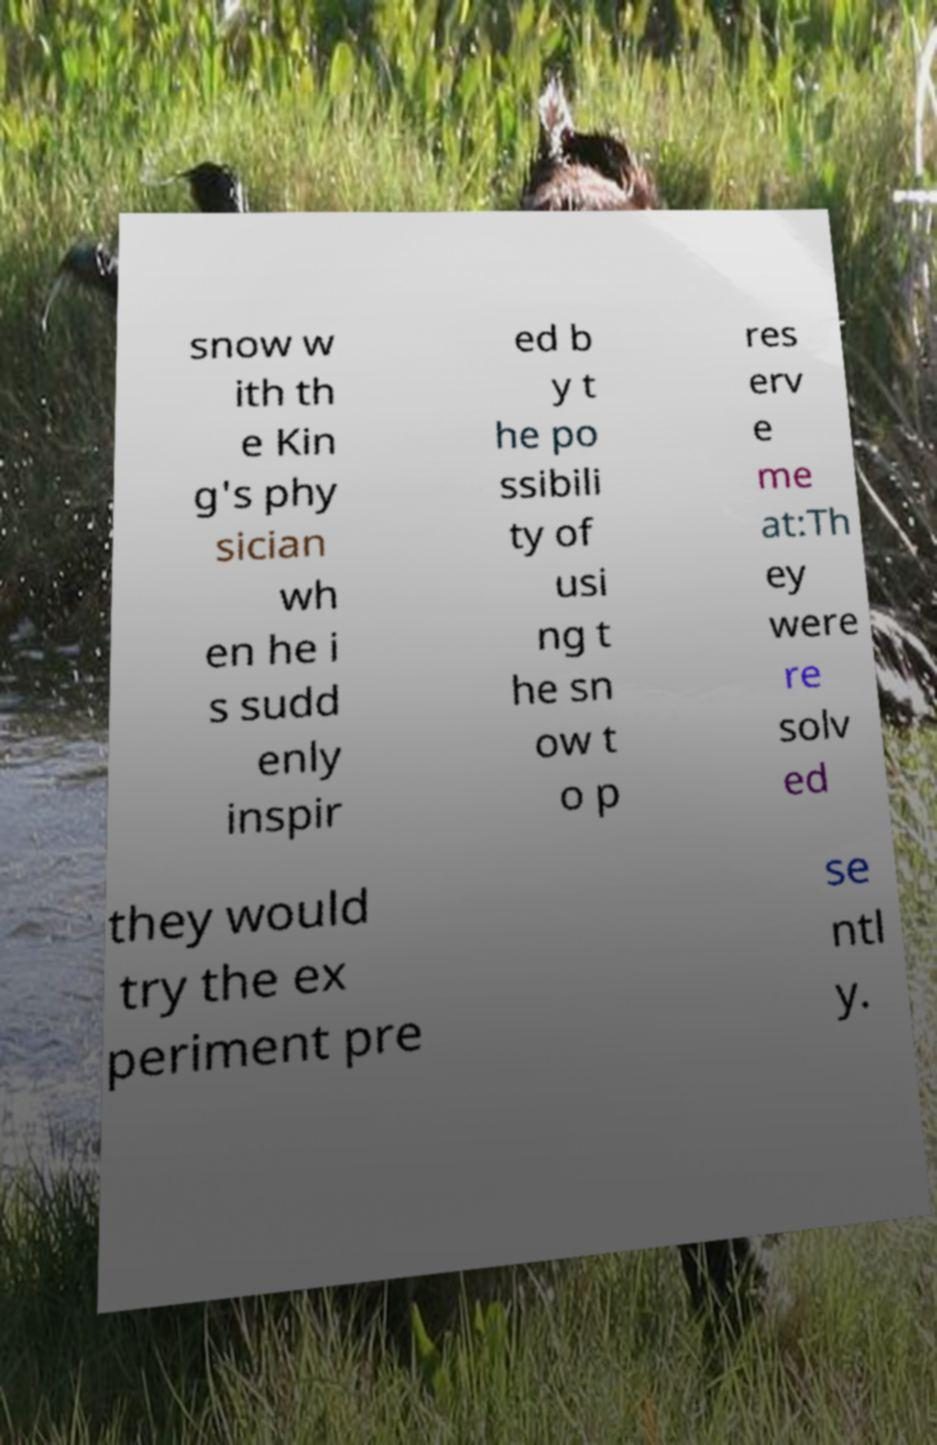Please read and relay the text visible in this image. What does it say? snow w ith th e Kin g's phy sician wh en he i s sudd enly inspir ed b y t he po ssibili ty of usi ng t he sn ow t o p res erv e me at:Th ey were re solv ed they would try the ex periment pre se ntl y. 